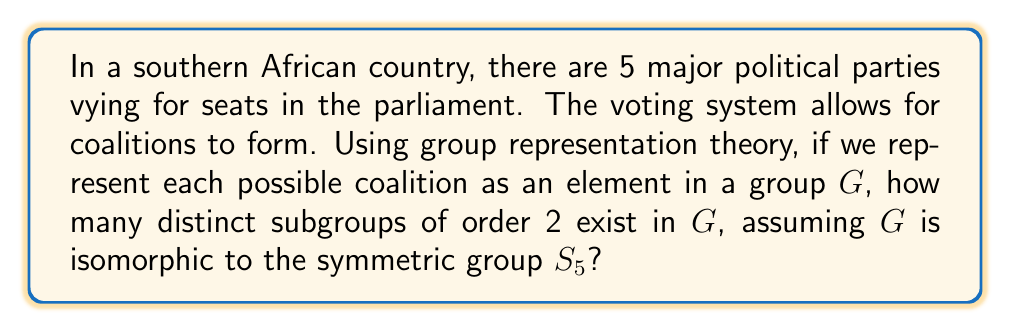Give your solution to this math problem. Let's approach this step-by-step:

1) First, we need to understand that the symmetric group $S_5$ represents all possible permutations of 5 elements, which in this case can be thought of as all possible arrangements of the 5 political parties.

2) In group theory, subgroups of order 2 are called involutions. These are elements that, when applied twice, return to the identity.

3) In $S_5$, involutions come in two types:
   a) Transpositions (2-cycles)
   b) Products of two disjoint transpositions

4) To count the number of transpositions:
   - We choose 2 elements out of 5 to swap
   - This can be done in $\binom{5}{2} = 10$ ways

5) To count the number of products of two disjoint transpositions:
   - We first choose 4 elements out of 5: $\binom{5}{4} = 5$
   - Then we split these 4 into two pairs in $\frac{4!}{2!2!2!} = 3$ ways
   - So there are $5 \times 3 = 15$ such elements

6) The total number of involutions is thus:
   $$ 10 + 15 = 25 $$

7) Each involution generates a subgroup of order 2.

Therefore, there are 25 distinct subgroups of order 2 in $G$.
Answer: 25 